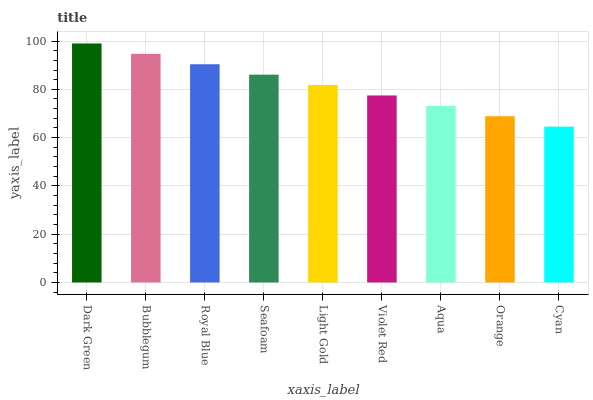Is Cyan the minimum?
Answer yes or no. Yes. Is Dark Green the maximum?
Answer yes or no. Yes. Is Bubblegum the minimum?
Answer yes or no. No. Is Bubblegum the maximum?
Answer yes or no. No. Is Dark Green greater than Bubblegum?
Answer yes or no. Yes. Is Bubblegum less than Dark Green?
Answer yes or no. Yes. Is Bubblegum greater than Dark Green?
Answer yes or no. No. Is Dark Green less than Bubblegum?
Answer yes or no. No. Is Light Gold the high median?
Answer yes or no. Yes. Is Light Gold the low median?
Answer yes or no. Yes. Is Royal Blue the high median?
Answer yes or no. No. Is Aqua the low median?
Answer yes or no. No. 